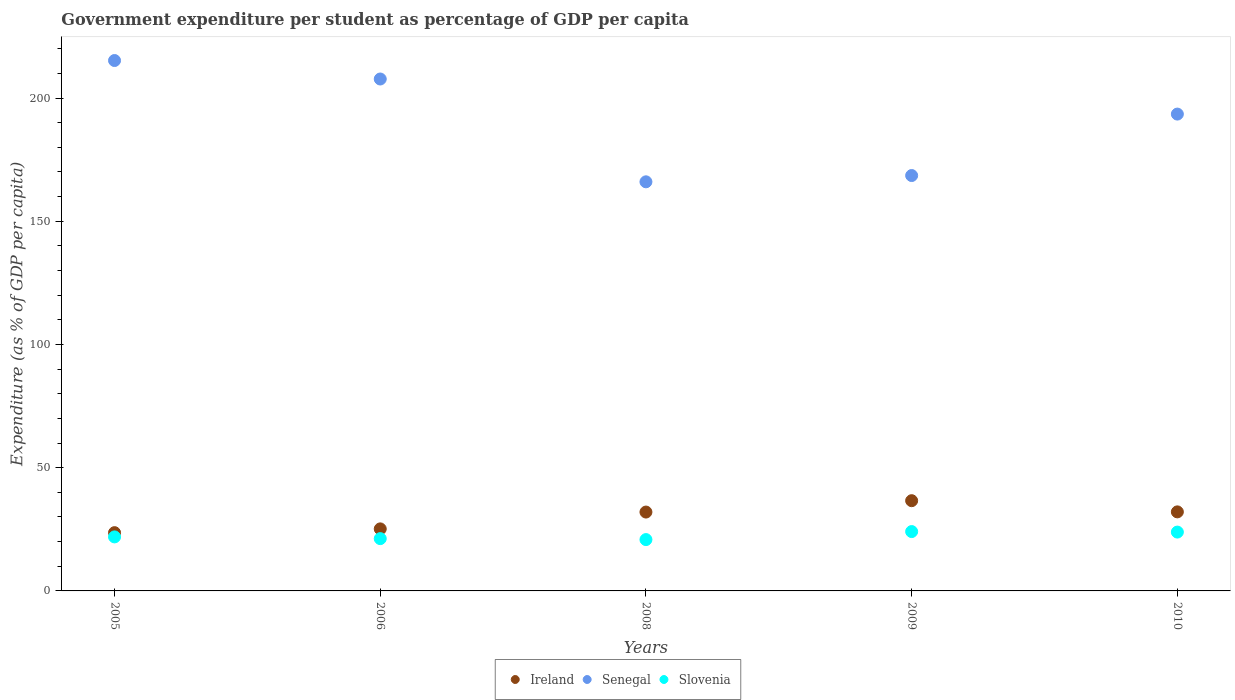How many different coloured dotlines are there?
Provide a succinct answer. 3. Is the number of dotlines equal to the number of legend labels?
Give a very brief answer. Yes. What is the percentage of expenditure per student in Ireland in 2009?
Provide a short and direct response. 36.61. Across all years, what is the maximum percentage of expenditure per student in Ireland?
Give a very brief answer. 36.61. Across all years, what is the minimum percentage of expenditure per student in Slovenia?
Offer a terse response. 20.83. In which year was the percentage of expenditure per student in Slovenia minimum?
Your answer should be very brief. 2008. What is the total percentage of expenditure per student in Ireland in the graph?
Offer a very short reply. 149.5. What is the difference between the percentage of expenditure per student in Slovenia in 2008 and that in 2009?
Provide a short and direct response. -3.25. What is the difference between the percentage of expenditure per student in Senegal in 2006 and the percentage of expenditure per student in Ireland in 2010?
Provide a succinct answer. 175.64. What is the average percentage of expenditure per student in Senegal per year?
Provide a short and direct response. 190.19. In the year 2008, what is the difference between the percentage of expenditure per student in Ireland and percentage of expenditure per student in Senegal?
Provide a succinct answer. -134. What is the ratio of the percentage of expenditure per student in Ireland in 2006 to that in 2010?
Your response must be concise. 0.78. Is the percentage of expenditure per student in Senegal in 2006 less than that in 2008?
Offer a very short reply. No. What is the difference between the highest and the second highest percentage of expenditure per student in Slovenia?
Your answer should be compact. 0.2. What is the difference between the highest and the lowest percentage of expenditure per student in Ireland?
Your response must be concise. 12.97. In how many years, is the percentage of expenditure per student in Senegal greater than the average percentage of expenditure per student in Senegal taken over all years?
Ensure brevity in your answer.  3. Is the percentage of expenditure per student in Slovenia strictly greater than the percentage of expenditure per student in Senegal over the years?
Give a very brief answer. No. What is the difference between two consecutive major ticks on the Y-axis?
Offer a very short reply. 50. Does the graph contain any zero values?
Your response must be concise. No. Does the graph contain grids?
Your response must be concise. No. How are the legend labels stacked?
Your answer should be compact. Horizontal. What is the title of the graph?
Provide a succinct answer. Government expenditure per student as percentage of GDP per capita. Does "Luxembourg" appear as one of the legend labels in the graph?
Give a very brief answer. No. What is the label or title of the Y-axis?
Ensure brevity in your answer.  Expenditure (as % of GDP per capita). What is the Expenditure (as % of GDP per capita) of Ireland in 2005?
Offer a terse response. 23.64. What is the Expenditure (as % of GDP per capita) of Senegal in 2005?
Your answer should be very brief. 215.21. What is the Expenditure (as % of GDP per capita) in Slovenia in 2005?
Offer a terse response. 21.92. What is the Expenditure (as % of GDP per capita) in Ireland in 2006?
Provide a succinct answer. 25.17. What is the Expenditure (as % of GDP per capita) of Senegal in 2006?
Your response must be concise. 207.71. What is the Expenditure (as % of GDP per capita) in Slovenia in 2006?
Your response must be concise. 21.22. What is the Expenditure (as % of GDP per capita) in Ireland in 2008?
Offer a terse response. 32. What is the Expenditure (as % of GDP per capita) in Senegal in 2008?
Provide a succinct answer. 166. What is the Expenditure (as % of GDP per capita) of Slovenia in 2008?
Your response must be concise. 20.83. What is the Expenditure (as % of GDP per capita) of Ireland in 2009?
Keep it short and to the point. 36.61. What is the Expenditure (as % of GDP per capita) in Senegal in 2009?
Provide a succinct answer. 168.54. What is the Expenditure (as % of GDP per capita) of Slovenia in 2009?
Provide a succinct answer. 24.08. What is the Expenditure (as % of GDP per capita) in Ireland in 2010?
Your response must be concise. 32.07. What is the Expenditure (as % of GDP per capita) in Senegal in 2010?
Provide a short and direct response. 193.48. What is the Expenditure (as % of GDP per capita) in Slovenia in 2010?
Your answer should be very brief. 23.88. Across all years, what is the maximum Expenditure (as % of GDP per capita) in Ireland?
Ensure brevity in your answer.  36.61. Across all years, what is the maximum Expenditure (as % of GDP per capita) of Senegal?
Keep it short and to the point. 215.21. Across all years, what is the maximum Expenditure (as % of GDP per capita) of Slovenia?
Offer a terse response. 24.08. Across all years, what is the minimum Expenditure (as % of GDP per capita) of Ireland?
Give a very brief answer. 23.64. Across all years, what is the minimum Expenditure (as % of GDP per capita) of Senegal?
Your answer should be compact. 166. Across all years, what is the minimum Expenditure (as % of GDP per capita) of Slovenia?
Offer a very short reply. 20.83. What is the total Expenditure (as % of GDP per capita) in Ireland in the graph?
Provide a short and direct response. 149.5. What is the total Expenditure (as % of GDP per capita) of Senegal in the graph?
Keep it short and to the point. 950.94. What is the total Expenditure (as % of GDP per capita) of Slovenia in the graph?
Offer a very short reply. 111.92. What is the difference between the Expenditure (as % of GDP per capita) of Ireland in 2005 and that in 2006?
Your response must be concise. -1.53. What is the difference between the Expenditure (as % of GDP per capita) in Senegal in 2005 and that in 2006?
Ensure brevity in your answer.  7.5. What is the difference between the Expenditure (as % of GDP per capita) of Slovenia in 2005 and that in 2006?
Keep it short and to the point. 0.7. What is the difference between the Expenditure (as % of GDP per capita) of Ireland in 2005 and that in 2008?
Ensure brevity in your answer.  -8.36. What is the difference between the Expenditure (as % of GDP per capita) in Senegal in 2005 and that in 2008?
Provide a short and direct response. 49.21. What is the difference between the Expenditure (as % of GDP per capita) in Slovenia in 2005 and that in 2008?
Offer a very short reply. 1.09. What is the difference between the Expenditure (as % of GDP per capita) of Ireland in 2005 and that in 2009?
Ensure brevity in your answer.  -12.97. What is the difference between the Expenditure (as % of GDP per capita) in Senegal in 2005 and that in 2009?
Keep it short and to the point. 46.67. What is the difference between the Expenditure (as % of GDP per capita) in Slovenia in 2005 and that in 2009?
Provide a short and direct response. -2.16. What is the difference between the Expenditure (as % of GDP per capita) in Ireland in 2005 and that in 2010?
Your answer should be very brief. -8.43. What is the difference between the Expenditure (as % of GDP per capita) in Senegal in 2005 and that in 2010?
Ensure brevity in your answer.  21.73. What is the difference between the Expenditure (as % of GDP per capita) of Slovenia in 2005 and that in 2010?
Keep it short and to the point. -1.96. What is the difference between the Expenditure (as % of GDP per capita) in Ireland in 2006 and that in 2008?
Provide a short and direct response. -6.83. What is the difference between the Expenditure (as % of GDP per capita) of Senegal in 2006 and that in 2008?
Your answer should be very brief. 41.72. What is the difference between the Expenditure (as % of GDP per capita) in Slovenia in 2006 and that in 2008?
Keep it short and to the point. 0.39. What is the difference between the Expenditure (as % of GDP per capita) in Ireland in 2006 and that in 2009?
Give a very brief answer. -11.44. What is the difference between the Expenditure (as % of GDP per capita) in Senegal in 2006 and that in 2009?
Your answer should be very brief. 39.17. What is the difference between the Expenditure (as % of GDP per capita) in Slovenia in 2006 and that in 2009?
Offer a very short reply. -2.86. What is the difference between the Expenditure (as % of GDP per capita) of Ireland in 2006 and that in 2010?
Give a very brief answer. -6.9. What is the difference between the Expenditure (as % of GDP per capita) of Senegal in 2006 and that in 2010?
Make the answer very short. 14.24. What is the difference between the Expenditure (as % of GDP per capita) in Slovenia in 2006 and that in 2010?
Offer a terse response. -2.66. What is the difference between the Expenditure (as % of GDP per capita) in Ireland in 2008 and that in 2009?
Your response must be concise. -4.61. What is the difference between the Expenditure (as % of GDP per capita) in Senegal in 2008 and that in 2009?
Offer a terse response. -2.55. What is the difference between the Expenditure (as % of GDP per capita) of Slovenia in 2008 and that in 2009?
Give a very brief answer. -3.25. What is the difference between the Expenditure (as % of GDP per capita) in Ireland in 2008 and that in 2010?
Offer a terse response. -0.07. What is the difference between the Expenditure (as % of GDP per capita) in Senegal in 2008 and that in 2010?
Your answer should be compact. -27.48. What is the difference between the Expenditure (as % of GDP per capita) of Slovenia in 2008 and that in 2010?
Offer a terse response. -3.05. What is the difference between the Expenditure (as % of GDP per capita) of Ireland in 2009 and that in 2010?
Ensure brevity in your answer.  4.54. What is the difference between the Expenditure (as % of GDP per capita) of Senegal in 2009 and that in 2010?
Offer a terse response. -24.93. What is the difference between the Expenditure (as % of GDP per capita) in Slovenia in 2009 and that in 2010?
Make the answer very short. 0.2. What is the difference between the Expenditure (as % of GDP per capita) in Ireland in 2005 and the Expenditure (as % of GDP per capita) in Senegal in 2006?
Give a very brief answer. -184.07. What is the difference between the Expenditure (as % of GDP per capita) of Ireland in 2005 and the Expenditure (as % of GDP per capita) of Slovenia in 2006?
Offer a terse response. 2.42. What is the difference between the Expenditure (as % of GDP per capita) of Senegal in 2005 and the Expenditure (as % of GDP per capita) of Slovenia in 2006?
Provide a short and direct response. 193.99. What is the difference between the Expenditure (as % of GDP per capita) of Ireland in 2005 and the Expenditure (as % of GDP per capita) of Senegal in 2008?
Your answer should be very brief. -142.36. What is the difference between the Expenditure (as % of GDP per capita) of Ireland in 2005 and the Expenditure (as % of GDP per capita) of Slovenia in 2008?
Provide a short and direct response. 2.81. What is the difference between the Expenditure (as % of GDP per capita) of Senegal in 2005 and the Expenditure (as % of GDP per capita) of Slovenia in 2008?
Your response must be concise. 194.38. What is the difference between the Expenditure (as % of GDP per capita) in Ireland in 2005 and the Expenditure (as % of GDP per capita) in Senegal in 2009?
Offer a terse response. -144.9. What is the difference between the Expenditure (as % of GDP per capita) of Ireland in 2005 and the Expenditure (as % of GDP per capita) of Slovenia in 2009?
Offer a terse response. -0.44. What is the difference between the Expenditure (as % of GDP per capita) in Senegal in 2005 and the Expenditure (as % of GDP per capita) in Slovenia in 2009?
Your answer should be very brief. 191.13. What is the difference between the Expenditure (as % of GDP per capita) of Ireland in 2005 and the Expenditure (as % of GDP per capita) of Senegal in 2010?
Offer a terse response. -169.84. What is the difference between the Expenditure (as % of GDP per capita) of Ireland in 2005 and the Expenditure (as % of GDP per capita) of Slovenia in 2010?
Your response must be concise. -0.24. What is the difference between the Expenditure (as % of GDP per capita) in Senegal in 2005 and the Expenditure (as % of GDP per capita) in Slovenia in 2010?
Ensure brevity in your answer.  191.33. What is the difference between the Expenditure (as % of GDP per capita) of Ireland in 2006 and the Expenditure (as % of GDP per capita) of Senegal in 2008?
Ensure brevity in your answer.  -140.82. What is the difference between the Expenditure (as % of GDP per capita) in Ireland in 2006 and the Expenditure (as % of GDP per capita) in Slovenia in 2008?
Your response must be concise. 4.34. What is the difference between the Expenditure (as % of GDP per capita) in Senegal in 2006 and the Expenditure (as % of GDP per capita) in Slovenia in 2008?
Make the answer very short. 186.88. What is the difference between the Expenditure (as % of GDP per capita) in Ireland in 2006 and the Expenditure (as % of GDP per capita) in Senegal in 2009?
Your response must be concise. -143.37. What is the difference between the Expenditure (as % of GDP per capita) in Ireland in 2006 and the Expenditure (as % of GDP per capita) in Slovenia in 2009?
Provide a short and direct response. 1.09. What is the difference between the Expenditure (as % of GDP per capita) of Senegal in 2006 and the Expenditure (as % of GDP per capita) of Slovenia in 2009?
Provide a succinct answer. 183.63. What is the difference between the Expenditure (as % of GDP per capita) in Ireland in 2006 and the Expenditure (as % of GDP per capita) in Senegal in 2010?
Provide a short and direct response. -168.3. What is the difference between the Expenditure (as % of GDP per capita) of Ireland in 2006 and the Expenditure (as % of GDP per capita) of Slovenia in 2010?
Make the answer very short. 1.3. What is the difference between the Expenditure (as % of GDP per capita) in Senegal in 2006 and the Expenditure (as % of GDP per capita) in Slovenia in 2010?
Your answer should be very brief. 183.84. What is the difference between the Expenditure (as % of GDP per capita) of Ireland in 2008 and the Expenditure (as % of GDP per capita) of Senegal in 2009?
Make the answer very short. -136.54. What is the difference between the Expenditure (as % of GDP per capita) in Ireland in 2008 and the Expenditure (as % of GDP per capita) in Slovenia in 2009?
Keep it short and to the point. 7.92. What is the difference between the Expenditure (as % of GDP per capita) in Senegal in 2008 and the Expenditure (as % of GDP per capita) in Slovenia in 2009?
Ensure brevity in your answer.  141.92. What is the difference between the Expenditure (as % of GDP per capita) of Ireland in 2008 and the Expenditure (as % of GDP per capita) of Senegal in 2010?
Provide a succinct answer. -161.48. What is the difference between the Expenditure (as % of GDP per capita) of Ireland in 2008 and the Expenditure (as % of GDP per capita) of Slovenia in 2010?
Your answer should be very brief. 8.12. What is the difference between the Expenditure (as % of GDP per capita) in Senegal in 2008 and the Expenditure (as % of GDP per capita) in Slovenia in 2010?
Your answer should be compact. 142.12. What is the difference between the Expenditure (as % of GDP per capita) of Ireland in 2009 and the Expenditure (as % of GDP per capita) of Senegal in 2010?
Offer a terse response. -156.86. What is the difference between the Expenditure (as % of GDP per capita) of Ireland in 2009 and the Expenditure (as % of GDP per capita) of Slovenia in 2010?
Provide a short and direct response. 12.74. What is the difference between the Expenditure (as % of GDP per capita) in Senegal in 2009 and the Expenditure (as % of GDP per capita) in Slovenia in 2010?
Keep it short and to the point. 144.67. What is the average Expenditure (as % of GDP per capita) of Ireland per year?
Offer a terse response. 29.9. What is the average Expenditure (as % of GDP per capita) of Senegal per year?
Provide a succinct answer. 190.19. What is the average Expenditure (as % of GDP per capita) of Slovenia per year?
Provide a short and direct response. 22.38. In the year 2005, what is the difference between the Expenditure (as % of GDP per capita) in Ireland and Expenditure (as % of GDP per capita) in Senegal?
Your answer should be very brief. -191.57. In the year 2005, what is the difference between the Expenditure (as % of GDP per capita) in Ireland and Expenditure (as % of GDP per capita) in Slovenia?
Your answer should be very brief. 1.72. In the year 2005, what is the difference between the Expenditure (as % of GDP per capita) of Senegal and Expenditure (as % of GDP per capita) of Slovenia?
Your answer should be very brief. 193.29. In the year 2006, what is the difference between the Expenditure (as % of GDP per capita) in Ireland and Expenditure (as % of GDP per capita) in Senegal?
Provide a succinct answer. -182.54. In the year 2006, what is the difference between the Expenditure (as % of GDP per capita) of Ireland and Expenditure (as % of GDP per capita) of Slovenia?
Make the answer very short. 3.95. In the year 2006, what is the difference between the Expenditure (as % of GDP per capita) of Senegal and Expenditure (as % of GDP per capita) of Slovenia?
Your answer should be very brief. 186.49. In the year 2008, what is the difference between the Expenditure (as % of GDP per capita) in Ireland and Expenditure (as % of GDP per capita) in Senegal?
Offer a very short reply. -134. In the year 2008, what is the difference between the Expenditure (as % of GDP per capita) of Ireland and Expenditure (as % of GDP per capita) of Slovenia?
Make the answer very short. 11.17. In the year 2008, what is the difference between the Expenditure (as % of GDP per capita) in Senegal and Expenditure (as % of GDP per capita) in Slovenia?
Offer a terse response. 145.17. In the year 2009, what is the difference between the Expenditure (as % of GDP per capita) in Ireland and Expenditure (as % of GDP per capita) in Senegal?
Your answer should be very brief. -131.93. In the year 2009, what is the difference between the Expenditure (as % of GDP per capita) of Ireland and Expenditure (as % of GDP per capita) of Slovenia?
Your answer should be very brief. 12.53. In the year 2009, what is the difference between the Expenditure (as % of GDP per capita) of Senegal and Expenditure (as % of GDP per capita) of Slovenia?
Offer a very short reply. 144.46. In the year 2010, what is the difference between the Expenditure (as % of GDP per capita) of Ireland and Expenditure (as % of GDP per capita) of Senegal?
Offer a very short reply. -161.4. In the year 2010, what is the difference between the Expenditure (as % of GDP per capita) of Ireland and Expenditure (as % of GDP per capita) of Slovenia?
Offer a very short reply. 8.2. In the year 2010, what is the difference between the Expenditure (as % of GDP per capita) in Senegal and Expenditure (as % of GDP per capita) in Slovenia?
Give a very brief answer. 169.6. What is the ratio of the Expenditure (as % of GDP per capita) of Ireland in 2005 to that in 2006?
Your answer should be very brief. 0.94. What is the ratio of the Expenditure (as % of GDP per capita) of Senegal in 2005 to that in 2006?
Your response must be concise. 1.04. What is the ratio of the Expenditure (as % of GDP per capita) of Slovenia in 2005 to that in 2006?
Give a very brief answer. 1.03. What is the ratio of the Expenditure (as % of GDP per capita) in Ireland in 2005 to that in 2008?
Keep it short and to the point. 0.74. What is the ratio of the Expenditure (as % of GDP per capita) in Senegal in 2005 to that in 2008?
Provide a succinct answer. 1.3. What is the ratio of the Expenditure (as % of GDP per capita) of Slovenia in 2005 to that in 2008?
Your response must be concise. 1.05. What is the ratio of the Expenditure (as % of GDP per capita) in Ireland in 2005 to that in 2009?
Ensure brevity in your answer.  0.65. What is the ratio of the Expenditure (as % of GDP per capita) in Senegal in 2005 to that in 2009?
Offer a very short reply. 1.28. What is the ratio of the Expenditure (as % of GDP per capita) of Slovenia in 2005 to that in 2009?
Your answer should be very brief. 0.91. What is the ratio of the Expenditure (as % of GDP per capita) of Ireland in 2005 to that in 2010?
Your answer should be very brief. 0.74. What is the ratio of the Expenditure (as % of GDP per capita) in Senegal in 2005 to that in 2010?
Provide a succinct answer. 1.11. What is the ratio of the Expenditure (as % of GDP per capita) in Slovenia in 2005 to that in 2010?
Your response must be concise. 0.92. What is the ratio of the Expenditure (as % of GDP per capita) in Ireland in 2006 to that in 2008?
Ensure brevity in your answer.  0.79. What is the ratio of the Expenditure (as % of GDP per capita) of Senegal in 2006 to that in 2008?
Offer a very short reply. 1.25. What is the ratio of the Expenditure (as % of GDP per capita) of Slovenia in 2006 to that in 2008?
Provide a succinct answer. 1.02. What is the ratio of the Expenditure (as % of GDP per capita) of Ireland in 2006 to that in 2009?
Give a very brief answer. 0.69. What is the ratio of the Expenditure (as % of GDP per capita) of Senegal in 2006 to that in 2009?
Keep it short and to the point. 1.23. What is the ratio of the Expenditure (as % of GDP per capita) of Slovenia in 2006 to that in 2009?
Offer a terse response. 0.88. What is the ratio of the Expenditure (as % of GDP per capita) in Ireland in 2006 to that in 2010?
Your response must be concise. 0.78. What is the ratio of the Expenditure (as % of GDP per capita) of Senegal in 2006 to that in 2010?
Ensure brevity in your answer.  1.07. What is the ratio of the Expenditure (as % of GDP per capita) in Slovenia in 2006 to that in 2010?
Your answer should be very brief. 0.89. What is the ratio of the Expenditure (as % of GDP per capita) in Ireland in 2008 to that in 2009?
Your answer should be very brief. 0.87. What is the ratio of the Expenditure (as % of GDP per capita) of Senegal in 2008 to that in 2009?
Offer a terse response. 0.98. What is the ratio of the Expenditure (as % of GDP per capita) in Slovenia in 2008 to that in 2009?
Give a very brief answer. 0.86. What is the ratio of the Expenditure (as % of GDP per capita) of Ireland in 2008 to that in 2010?
Your answer should be compact. 1. What is the ratio of the Expenditure (as % of GDP per capita) of Senegal in 2008 to that in 2010?
Provide a succinct answer. 0.86. What is the ratio of the Expenditure (as % of GDP per capita) in Slovenia in 2008 to that in 2010?
Offer a very short reply. 0.87. What is the ratio of the Expenditure (as % of GDP per capita) of Ireland in 2009 to that in 2010?
Offer a very short reply. 1.14. What is the ratio of the Expenditure (as % of GDP per capita) in Senegal in 2009 to that in 2010?
Provide a short and direct response. 0.87. What is the ratio of the Expenditure (as % of GDP per capita) in Slovenia in 2009 to that in 2010?
Offer a terse response. 1.01. What is the difference between the highest and the second highest Expenditure (as % of GDP per capita) of Ireland?
Offer a terse response. 4.54. What is the difference between the highest and the second highest Expenditure (as % of GDP per capita) in Senegal?
Offer a very short reply. 7.5. What is the difference between the highest and the second highest Expenditure (as % of GDP per capita) in Slovenia?
Provide a short and direct response. 0.2. What is the difference between the highest and the lowest Expenditure (as % of GDP per capita) of Ireland?
Your response must be concise. 12.97. What is the difference between the highest and the lowest Expenditure (as % of GDP per capita) of Senegal?
Keep it short and to the point. 49.21. What is the difference between the highest and the lowest Expenditure (as % of GDP per capita) in Slovenia?
Your response must be concise. 3.25. 